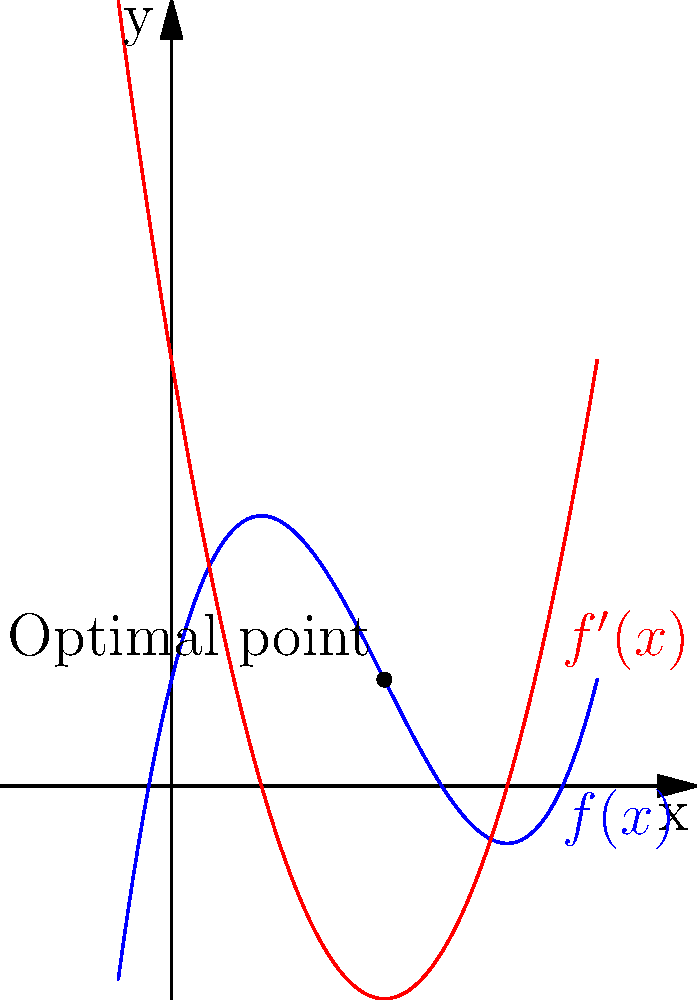Consider a database search algorithm whose efficiency is modeled by the function $f(x) = 0.5x^3 - 3x^2 + 4x + 1$, where $x$ represents the number of indexing levels and $f(x)$ represents the search time in milliseconds. The graph shows $f(x)$ and its derivative $f'(x)$. What is the optimal number of indexing levels to minimize search time, and what is this minimum search time? To find the optimal number of indexing levels and the minimum search time, we need to follow these steps:

1) The optimal point occurs where the derivative $f'(x)$ equals zero. This is because the derivative represents the rate of change of the function, and at the minimum point, this rate is zero.

2) From the graph, we can see that $f'(x)$ (the red curve) intersects the x-axis at $x = 2$. This is the point where $f'(x) = 0$.

3) To verify analytically:
   $f'(x) = 1.5x^2 - 6x + 4$
   Setting this equal to zero:
   $1.5x^2 - 6x + 4 = 0$
   This quadratic equation indeed has a solution at $x = 2$.

4) Therefore, the optimal number of indexing levels is 2.

5) To find the minimum search time, we need to evaluate $f(2)$:
   $f(2) = 0.5(2)^3 - 3(2)^2 + 4(2) + 1$
         $= 4 - 12 + 8 + 1$
         $= 1$ millisecond

Thus, the optimal number of indexing levels is 2, and the minimum search time is 1 millisecond.
Answer: 2 indexing levels; 1 millisecond 